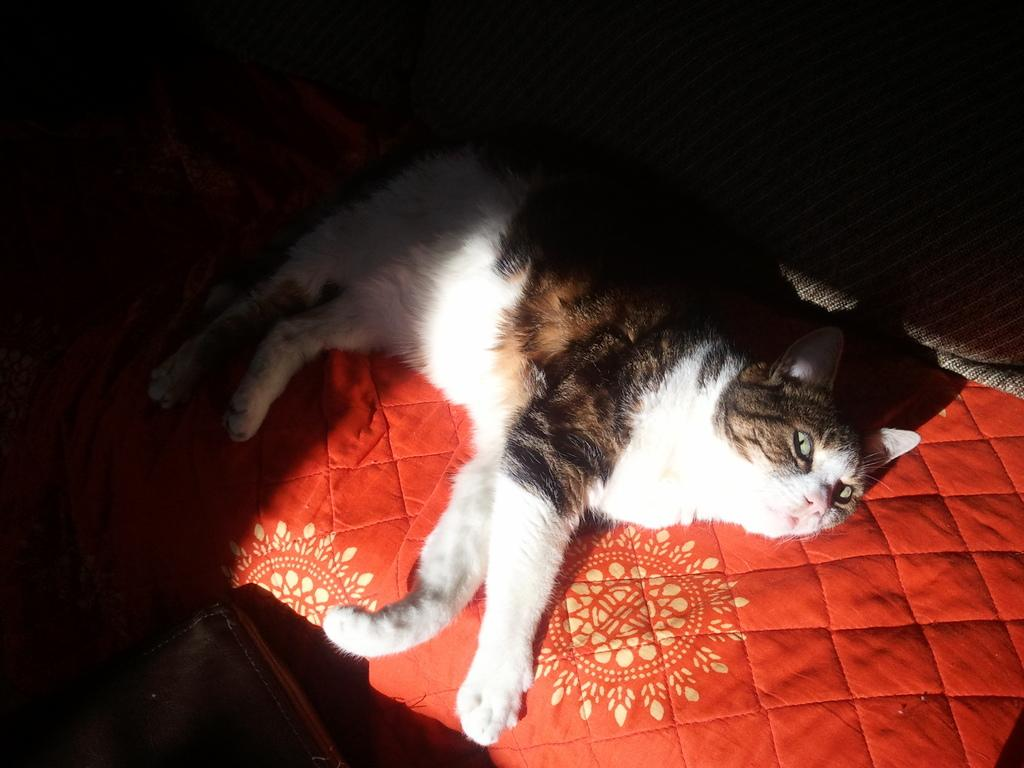What type of animal is in the image? There is a cat in the image. What colors can be seen on the cat? The cat has white, black, and brown colors. What is the cat sitting on in the image? The cat is on a red cloth. What color is the background of the image? The background of the image is black. What is the cat's opinion on the political situation in the image? The image does not provide any information about the cat's opinion on the political situation, as it is focused on the cat's appearance and location. 